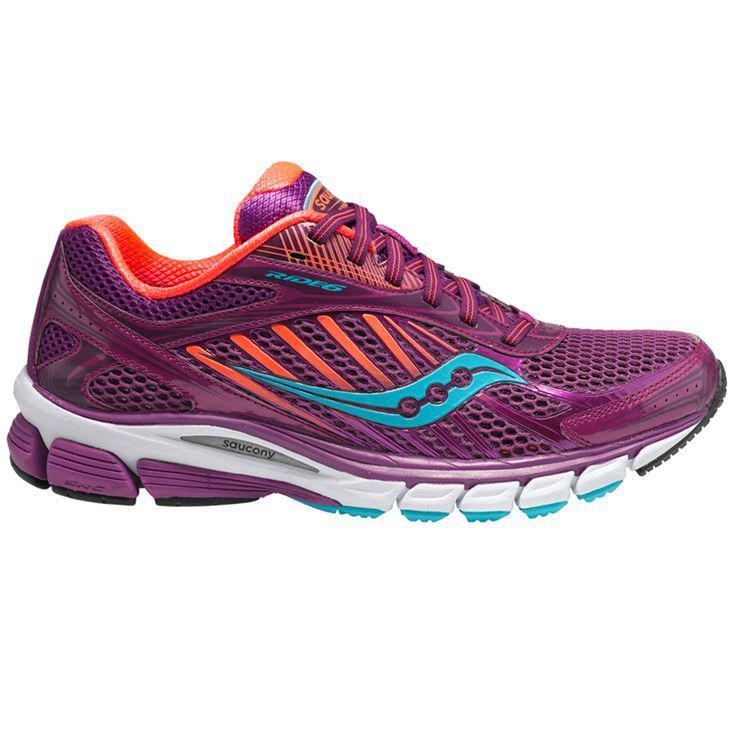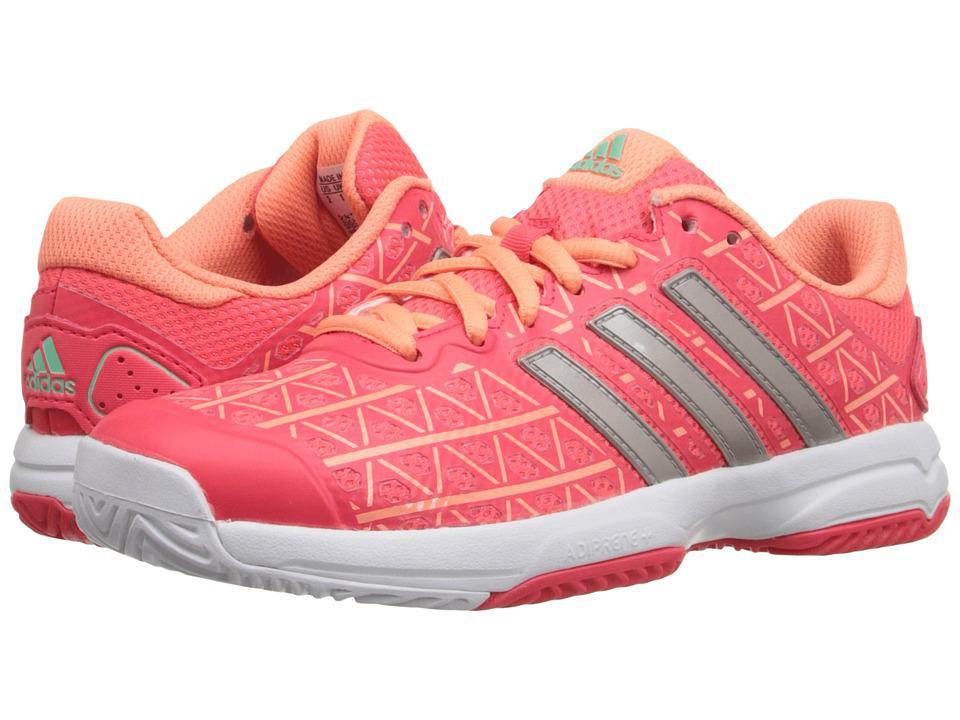The first image is the image on the left, the second image is the image on the right. Examine the images to the left and right. Is the description "The images show a total of two sneakers, both facing right." accurate? Answer yes or no. No. 